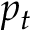Convert formula to latex. <formula><loc_0><loc_0><loc_500><loc_500>p _ { t }</formula> 